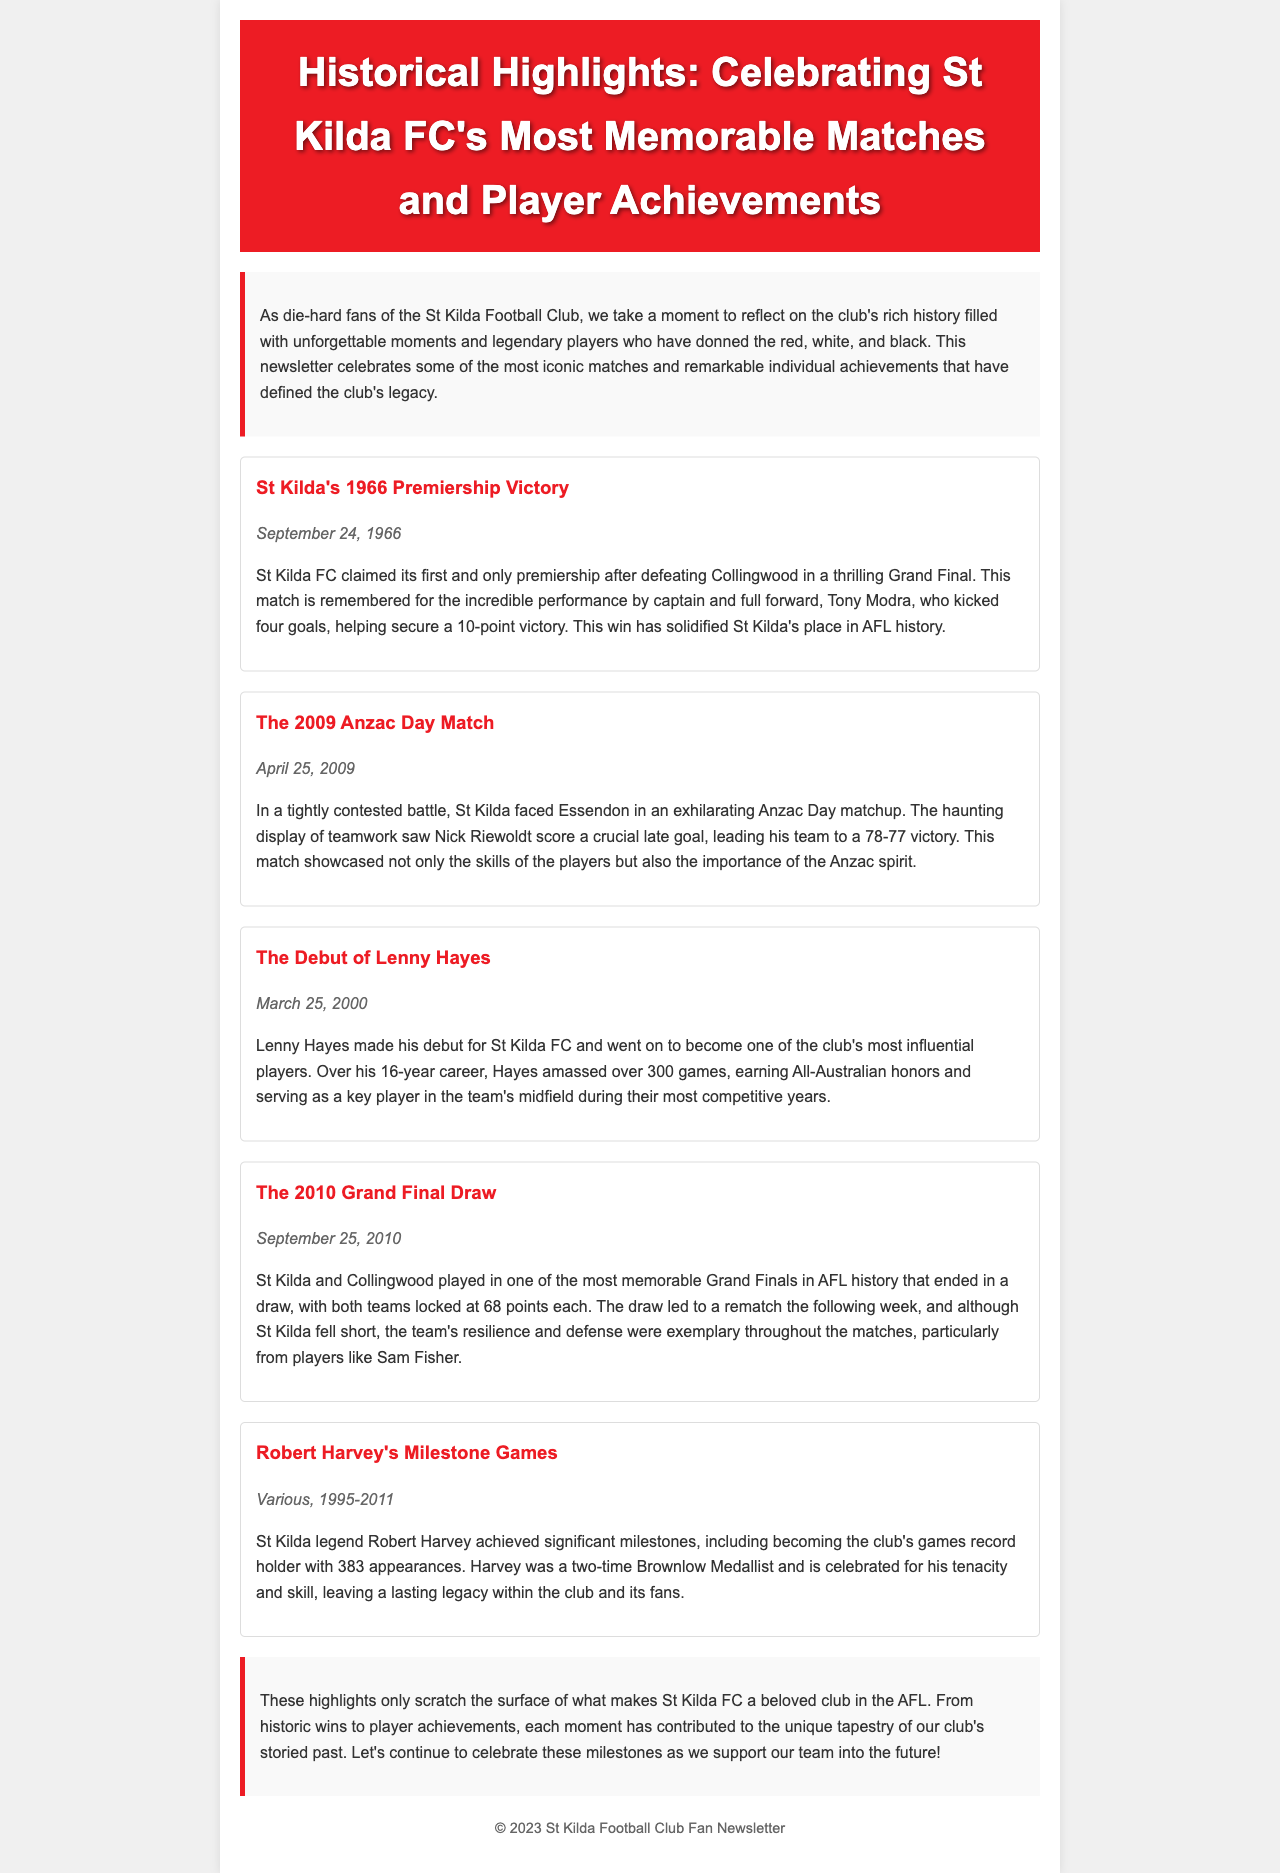What year did St Kilda win their first premiership? The document states that St Kilda won their first premiership in 1966.
Answer: 1966 Who was the captain during the 1966 premiership victory? The document mentions Tony Modra as the captain during St Kilda's 1966 premiership victory.
Answer: Tony Modra What significant event occurred on April 25, 2009? The document describes the match between St Kilda and Essendon as the 2009 Anzac Day Match.
Answer: 2009 Anzac Day Match How many games did Lenny Hayes play? The document indicates that Lenny Hayes played over 300 games during his career at St Kilda.
Answer: Over 300 games What was the result of the 2010 Grand Final between St Kilda and Collingwood? The document states that the 2010 Grand Final ended in a draw.
Answer: A draw Who is St Kilda's games record holder? The document mentions Robert Harvey as the club's games record holder.
Answer: Robert Harvey Which player scored a crucial late goal in the 2009 Anzac Day Match? According to the document, Nick Riewoldt scored a crucial late goal in the 2009 Anzac Day Match.
Answer: Nick Riewoldt What two awards did Robert Harvey win during his career? The document notes that Robert Harvey was a two-time Brownlow Medallist.
Answer: Two-time Brownlow Medallist What did the document emphasize about St Kilda's history? The document emphasizes the club's rich history filled with unforgettable moments and legendary players.
Answer: Unforgettable moments and legendary players 